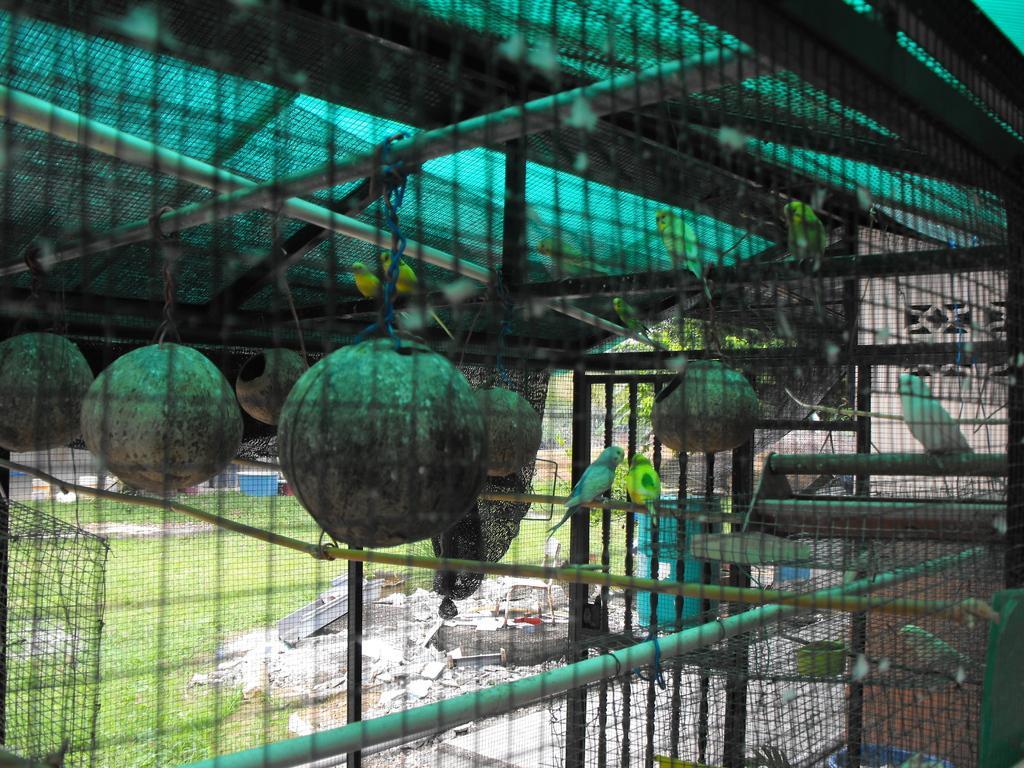Can you describe this image briefly? There is a cage with mesh. Inside the cage there are pots and birds. On the ground there is grass. 